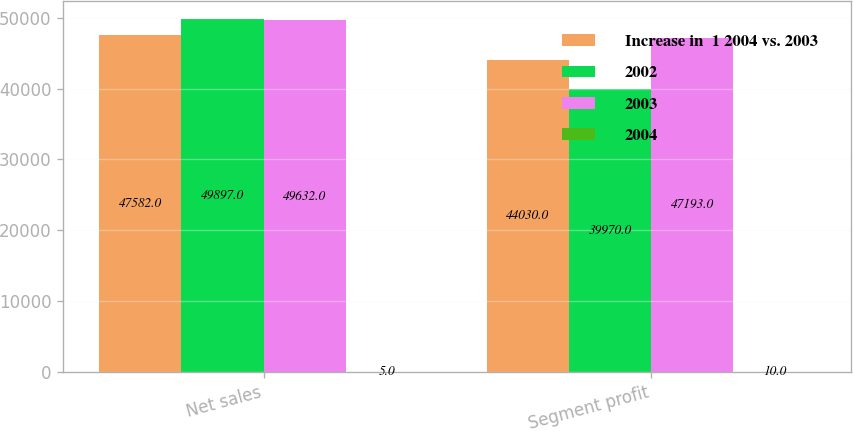<chart> <loc_0><loc_0><loc_500><loc_500><stacked_bar_chart><ecel><fcel>Net sales<fcel>Segment profit<nl><fcel>Increase in  1 2004 vs. 2003<fcel>47582<fcel>44030<nl><fcel>2002<fcel>49897<fcel>39970<nl><fcel>2003<fcel>49632<fcel>47193<nl><fcel>2004<fcel>5<fcel>10<nl></chart> 